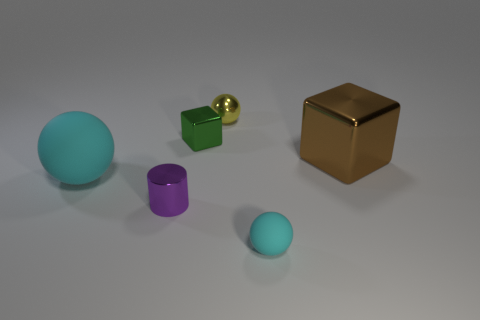How many cyan balls must be subtracted to get 1 cyan balls? 1 Add 4 small purple cylinders. How many objects exist? 10 Subtract all cylinders. How many objects are left? 5 Subtract all purple shiny cylinders. Subtract all tiny rubber cylinders. How many objects are left? 5 Add 3 matte balls. How many matte balls are left? 5 Add 5 green objects. How many green objects exist? 6 Subtract 0 brown cylinders. How many objects are left? 6 